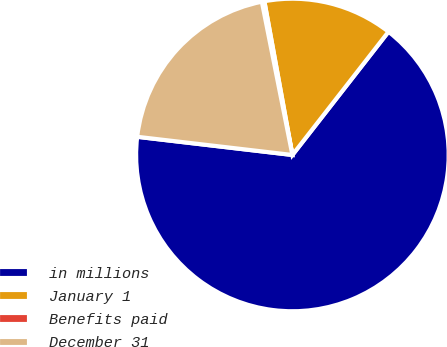Convert chart. <chart><loc_0><loc_0><loc_500><loc_500><pie_chart><fcel>in millions<fcel>January 1<fcel>Benefits paid<fcel>December 31<nl><fcel>66.32%<fcel>13.41%<fcel>0.26%<fcel>20.01%<nl></chart> 